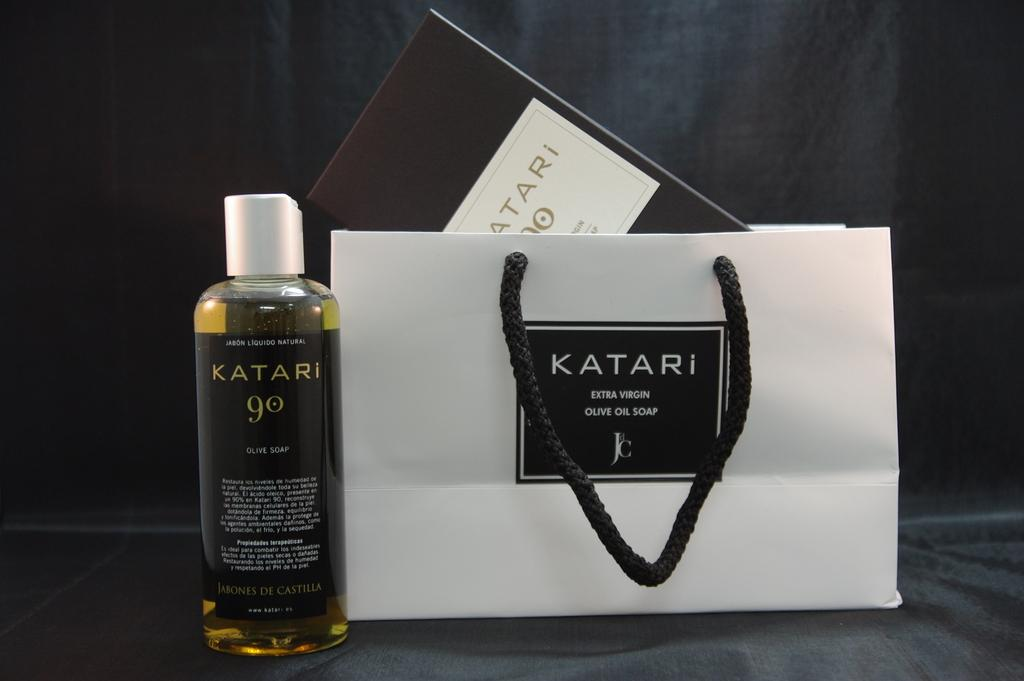<image>
Describe the image concisely. a bag that has the word Katari on it 